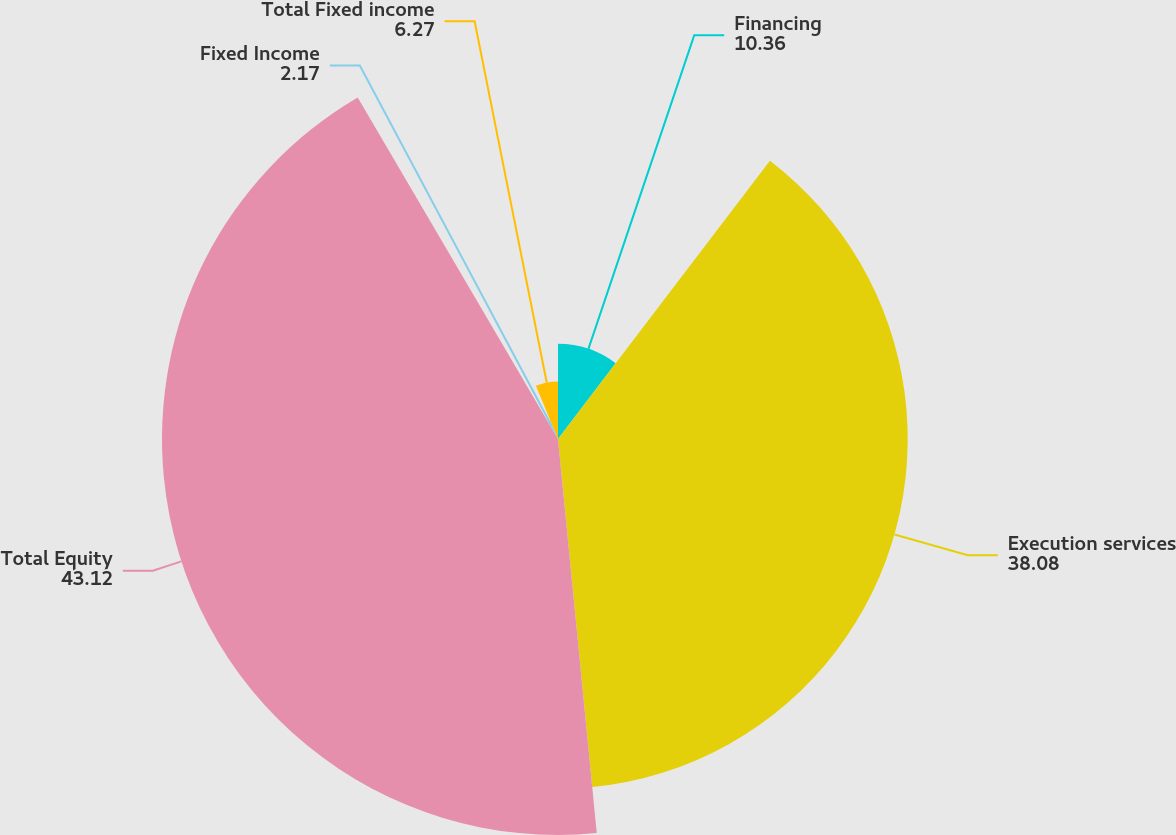Convert chart to OTSL. <chart><loc_0><loc_0><loc_500><loc_500><pie_chart><fcel>Financing<fcel>Execution services<fcel>Total Equity<fcel>Fixed Income<fcel>Total Fixed income<nl><fcel>10.36%<fcel>38.08%<fcel>43.12%<fcel>2.17%<fcel>6.27%<nl></chart> 